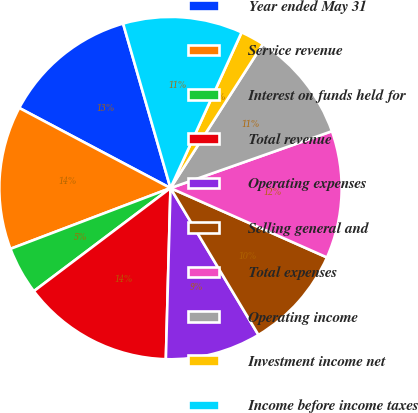Convert chart. <chart><loc_0><loc_0><loc_500><loc_500><pie_chart><fcel>Year ended May 31<fcel>Service revenue<fcel>Interest on funds held for<fcel>Total revenue<fcel>Operating expenses<fcel>Selling general and<fcel>Total expenses<fcel>Operating income<fcel>Investment income net<fcel>Income before income taxes<nl><fcel>12.78%<fcel>13.53%<fcel>4.51%<fcel>14.28%<fcel>9.02%<fcel>9.77%<fcel>12.03%<fcel>10.53%<fcel>2.26%<fcel>11.28%<nl></chart> 